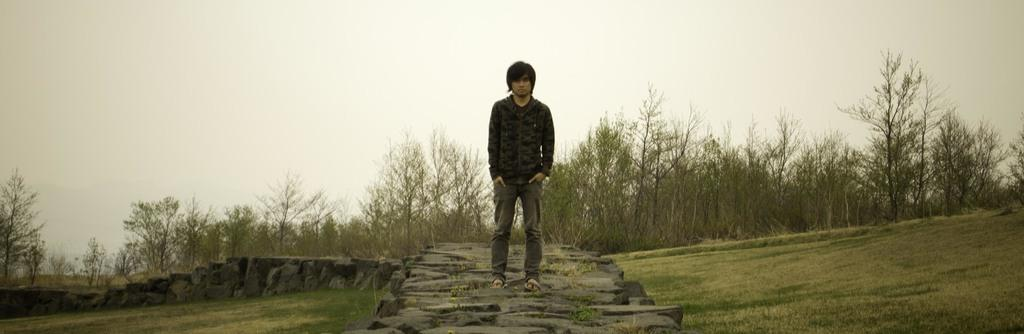Who is the main subject in the image? There is a boy in the image. What is the boy wearing? The boy is wearing a black t-shirt and grey pants. What is the boy doing in the image? The boy is standing on rocks and posing for the camera. What can be seen in the background of the image? There are trees visible in the background of the image. What type of island can be seen in the background of the image? There is no island visible in the background of the image; it features trees instead. What type of competition is the boy participating in? There is no competition present in the image; the boy is simply posing for the camera. 